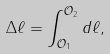Convert formula to latex. <formula><loc_0><loc_0><loc_500><loc_500>\Delta \ell = \int _ { \mathcal { O } _ { 1 } } ^ { \mathcal { O } _ { 2 } } d \ell ,</formula> 